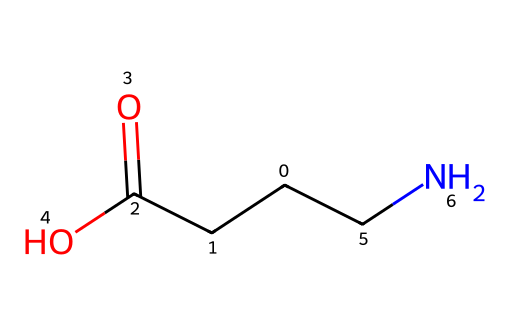What is the name of this chemical? The provided SMILES code corresponds to gamma-aminobutyric acid, which is a neurotransmitter. The structure includes a carboxylic acid group (COOH) and an amine group ( NH2) directly connected to the alpha carbon atom, indicating it’s an amino acid.
Answer: gamma-aminobutyric acid How many carbon atoms are present in this molecule? Counting the carbon atoms in the SMILES representation, we see 'C' appears three times, indicative of three carbon atoms in the structure.
Answer: 3 What type of functional groups does this compound contain? The structure includes a carboxylic acid group (-COOH) and an amine group (-NH2), making the molecule an amino acid that possesses both acidic and basic properties.
Answer: carboxylic acid and amine Is this molecule considered a strong or weak acid? Gamma-aminobutyric acid acts as a weak acid in biological systems due to its pKa values, generally not completely dissociating in solution, unlike strong acids.
Answer: weak acid What is the charge of this molecule at physiological pH? At physiological pH (around 7.4), gamma-aminobutyric acid typically carries a net charge of zero, as the carboxylic acid group is deprotonated (-COO-) and the amine group is protonated (-NH3+), balancing the total charge.
Answer: zero 